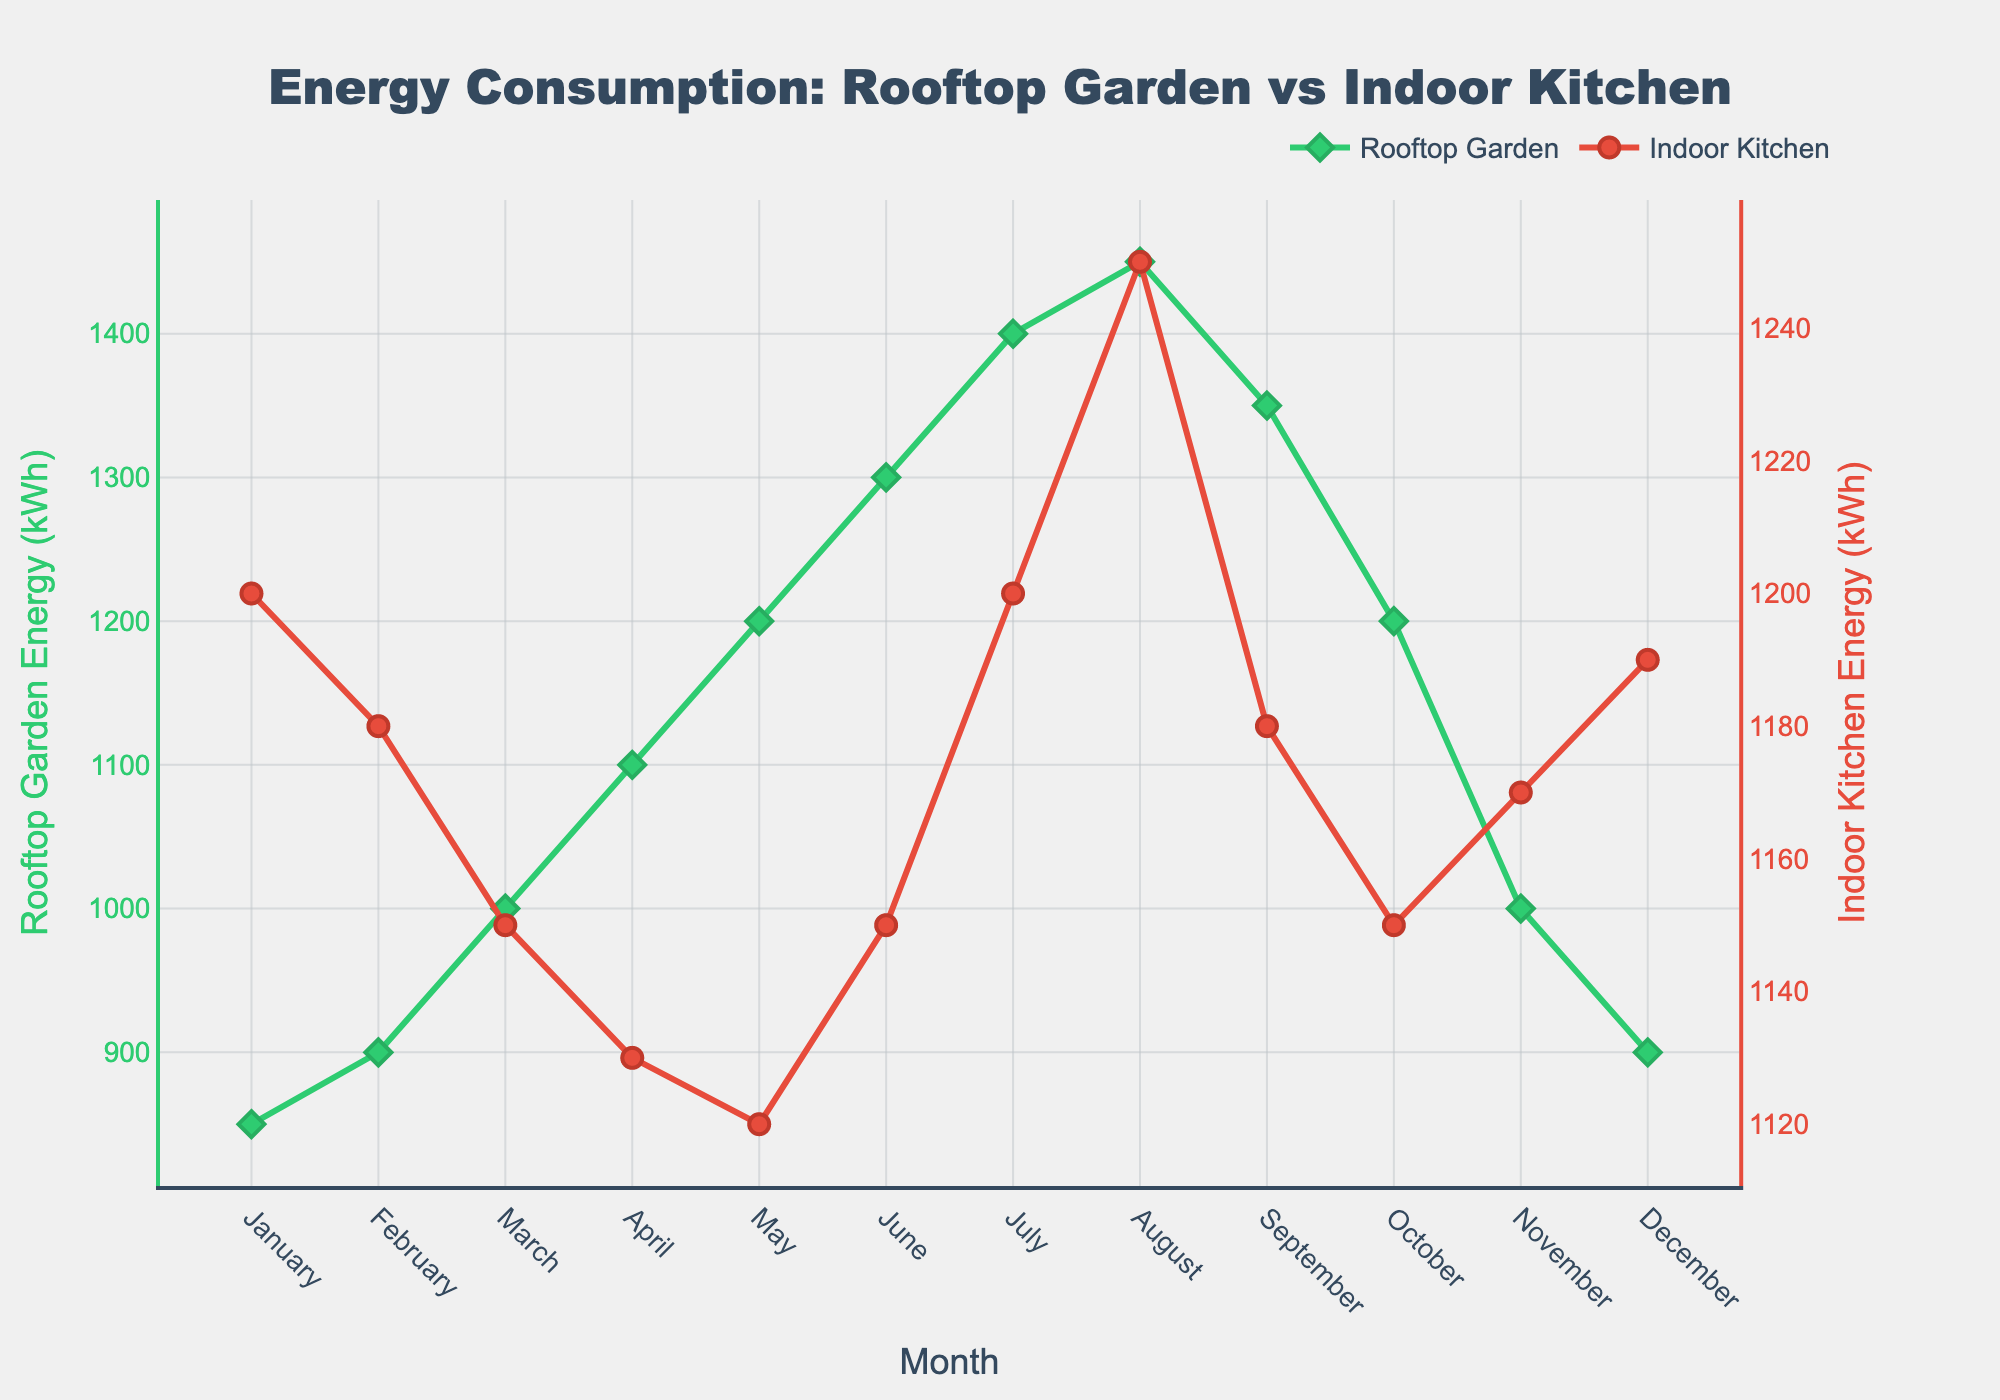Which month has the highest energy consumption for the rooftop garden? By looking at the green line representing rooftop garden energy consumption, we can see the peak occurs in August.
Answer: August In which month is the difference between the energy consumption of the rooftop garden and the indoor kitchen the smallest? By comparing the two lines, January shows the rooftop garden at 850 kWh and the indoor kitchen at 1200 kWh, while November shows the rooftop garden at 1000 kWh and indoor kitchen at 1170 kWh. The smallest difference occurs in November: 1170 - 1000 = 170 kWh.
Answer: November What is the average energy consumption for the rooftop garden over the entire year? Summing the rooftop garden's monthly energy consumption values: 850 + 900 + 1000 + 1100 + 1200 + 1300 + 1400 + 1450 + 1350 + 1200 + 1000 + 900 = 13650 kWh, and then dividing by 12 months: 13650 / 12 = 1137.5 kWh.
Answer: 1137.5 kWh Which season (quarter) has the highest total energy consumption for the indoor kitchen? Summing the energy consumption for each quarter:
Winter (Dec-Feb): 1190 + 1200 + 1180 = 3570 kWh
Spring (Mar-May): 1150 + 1130 + 1120 = 3400 kWh
Summer (Jun-Aug): 1150 + 1200 + 1250 = 3600 kWh
Fall (Sep-Nov): 1180 + 1150 + 1170 = 3500 kWh
The summer quarter has the highest at 3600 kWh.
Answer: Summer Does the energy consumption of the indoor kitchen show a clear downward trend over the year? By examining the red line, we see a moderate decrease initially, but later months show fluctuations with increases and decreases, not a clear consistent downward trend.
Answer: No During which month is the ratio of rooftop garden energy consumption to indoor kitchen energy consumption the highest? Calculate the ratio for each month and find the maximum:
January: 850/1200 = 0.708
February: 900/1180 = 0.763
March: 1000/1150 = 0.870
April: 1100/1130 = 0.973
May: 1200/1120 = 1.071
June: 1300/1150 = 1.130
July: 1400/1200 = 1.167
August: 1450/1250 = 1.160
September: 1350/1180 = 1.144
October: 1200/1150 = 1.043
November: 1000/1170 = 0.855
December: 900/1190 = 0.756
The highest ratio occurs in July: 1400/1200 = 1.167.
Answer: July Which month experiences the steepest increase in energy consumption for the rooftop garden compared to the previous month? Calculating the increase month to month:
Feb-Jan: 900-850 = 50 kWh
Mar-Feb: 1000-900 = 100 kWh
Apr-Mar: 1100-1000 = 100 kWh
May-Apr: 1200-1100 = 100 kWh
Jun-May: 1300-1200 = 100 kWh
Jul-Jun: 1400-1300 = 100 kWh
Aug-Jul: 1450-1400 = 50 kWh
Sep-Aug: 1350-1450 = -100 kWh
Oct-Sep: 1200-1350 = -150 kWh
Nov-Oct: 1000-1200 = -200 kWh
Dec-Nov: 900-1000 = -100 kWh
The steepest increase is from February to March at 100 kWh. There’s no month with a greater rise.
Answer: March 